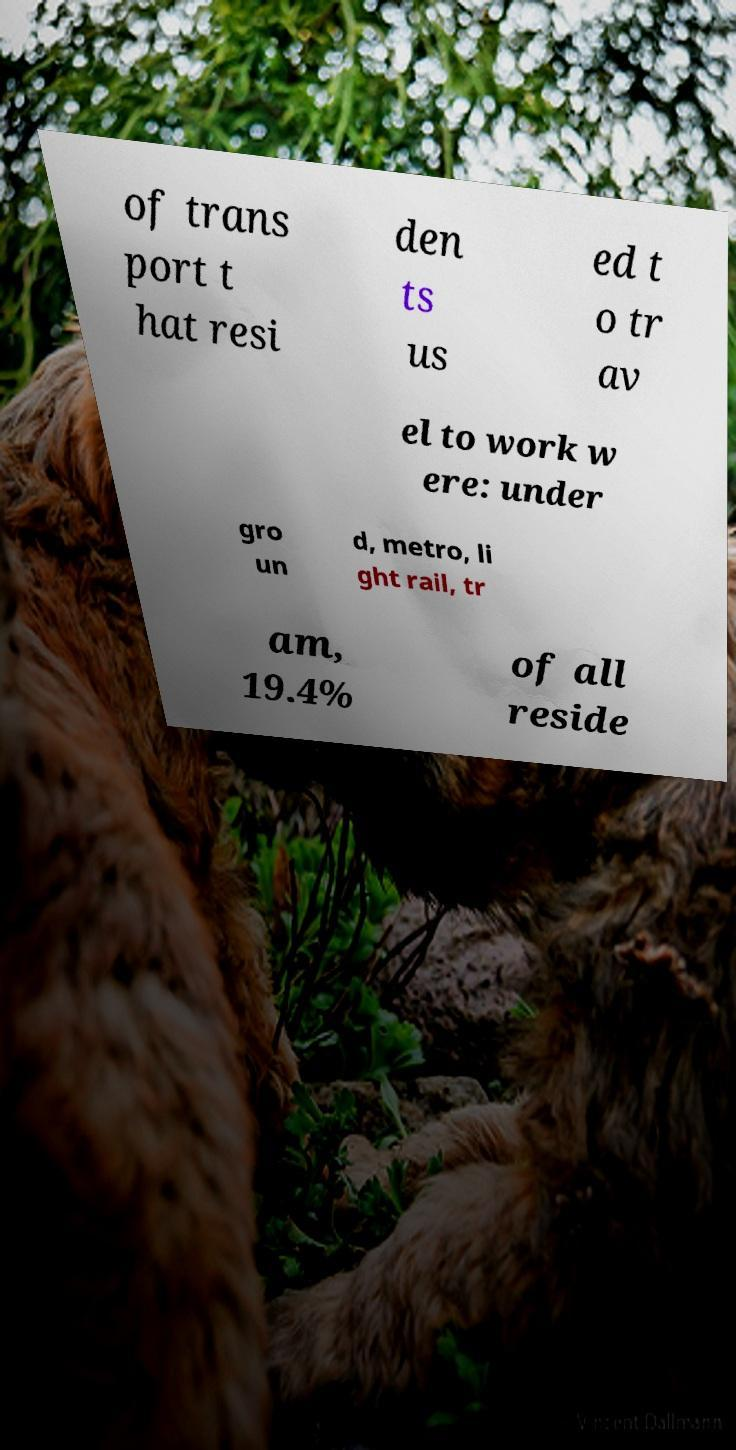For documentation purposes, I need the text within this image transcribed. Could you provide that? of trans port t hat resi den ts us ed t o tr av el to work w ere: under gro un d, metro, li ght rail, tr am, 19.4% of all reside 